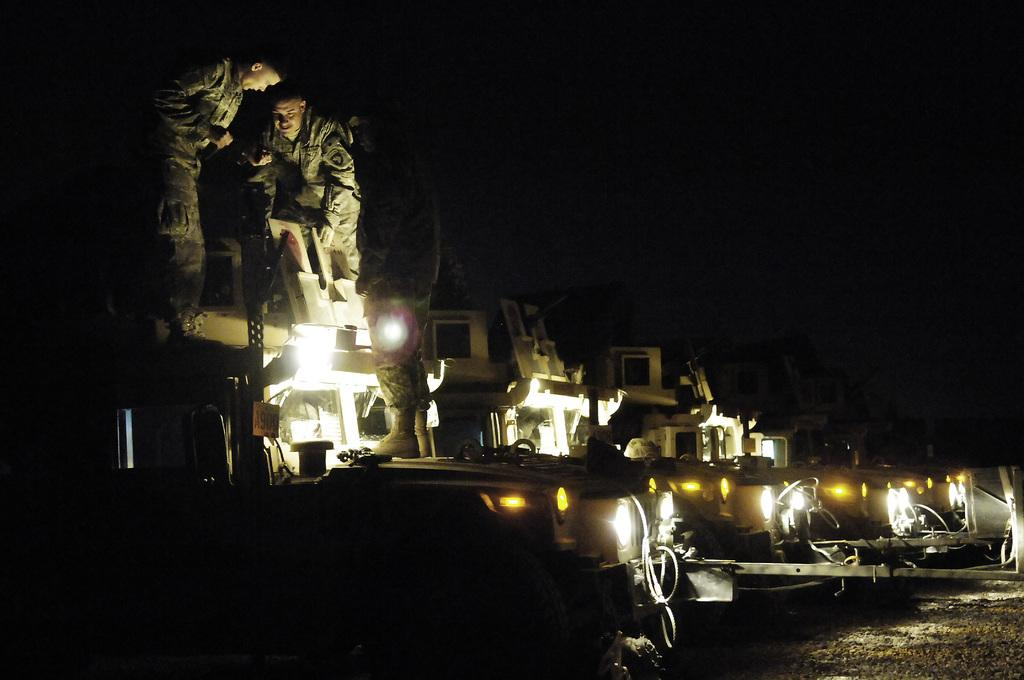What can be seen in the image? There are vehicles in the image. What are the men in the image doing? The men are standing on a vehicle. What is the lighting condition in the image? The image was taken in the dark. What type of stitch is being used to repair the vehicle in the image? There is no stitching or repair work visible in the image; it simply shows vehicles and men standing on one of them. How many fingers can be seen holding onto the vehicle in the image? The number of fingers cannot be determined from the image, as it only shows the men standing on the vehicle, not their individual fingers. 